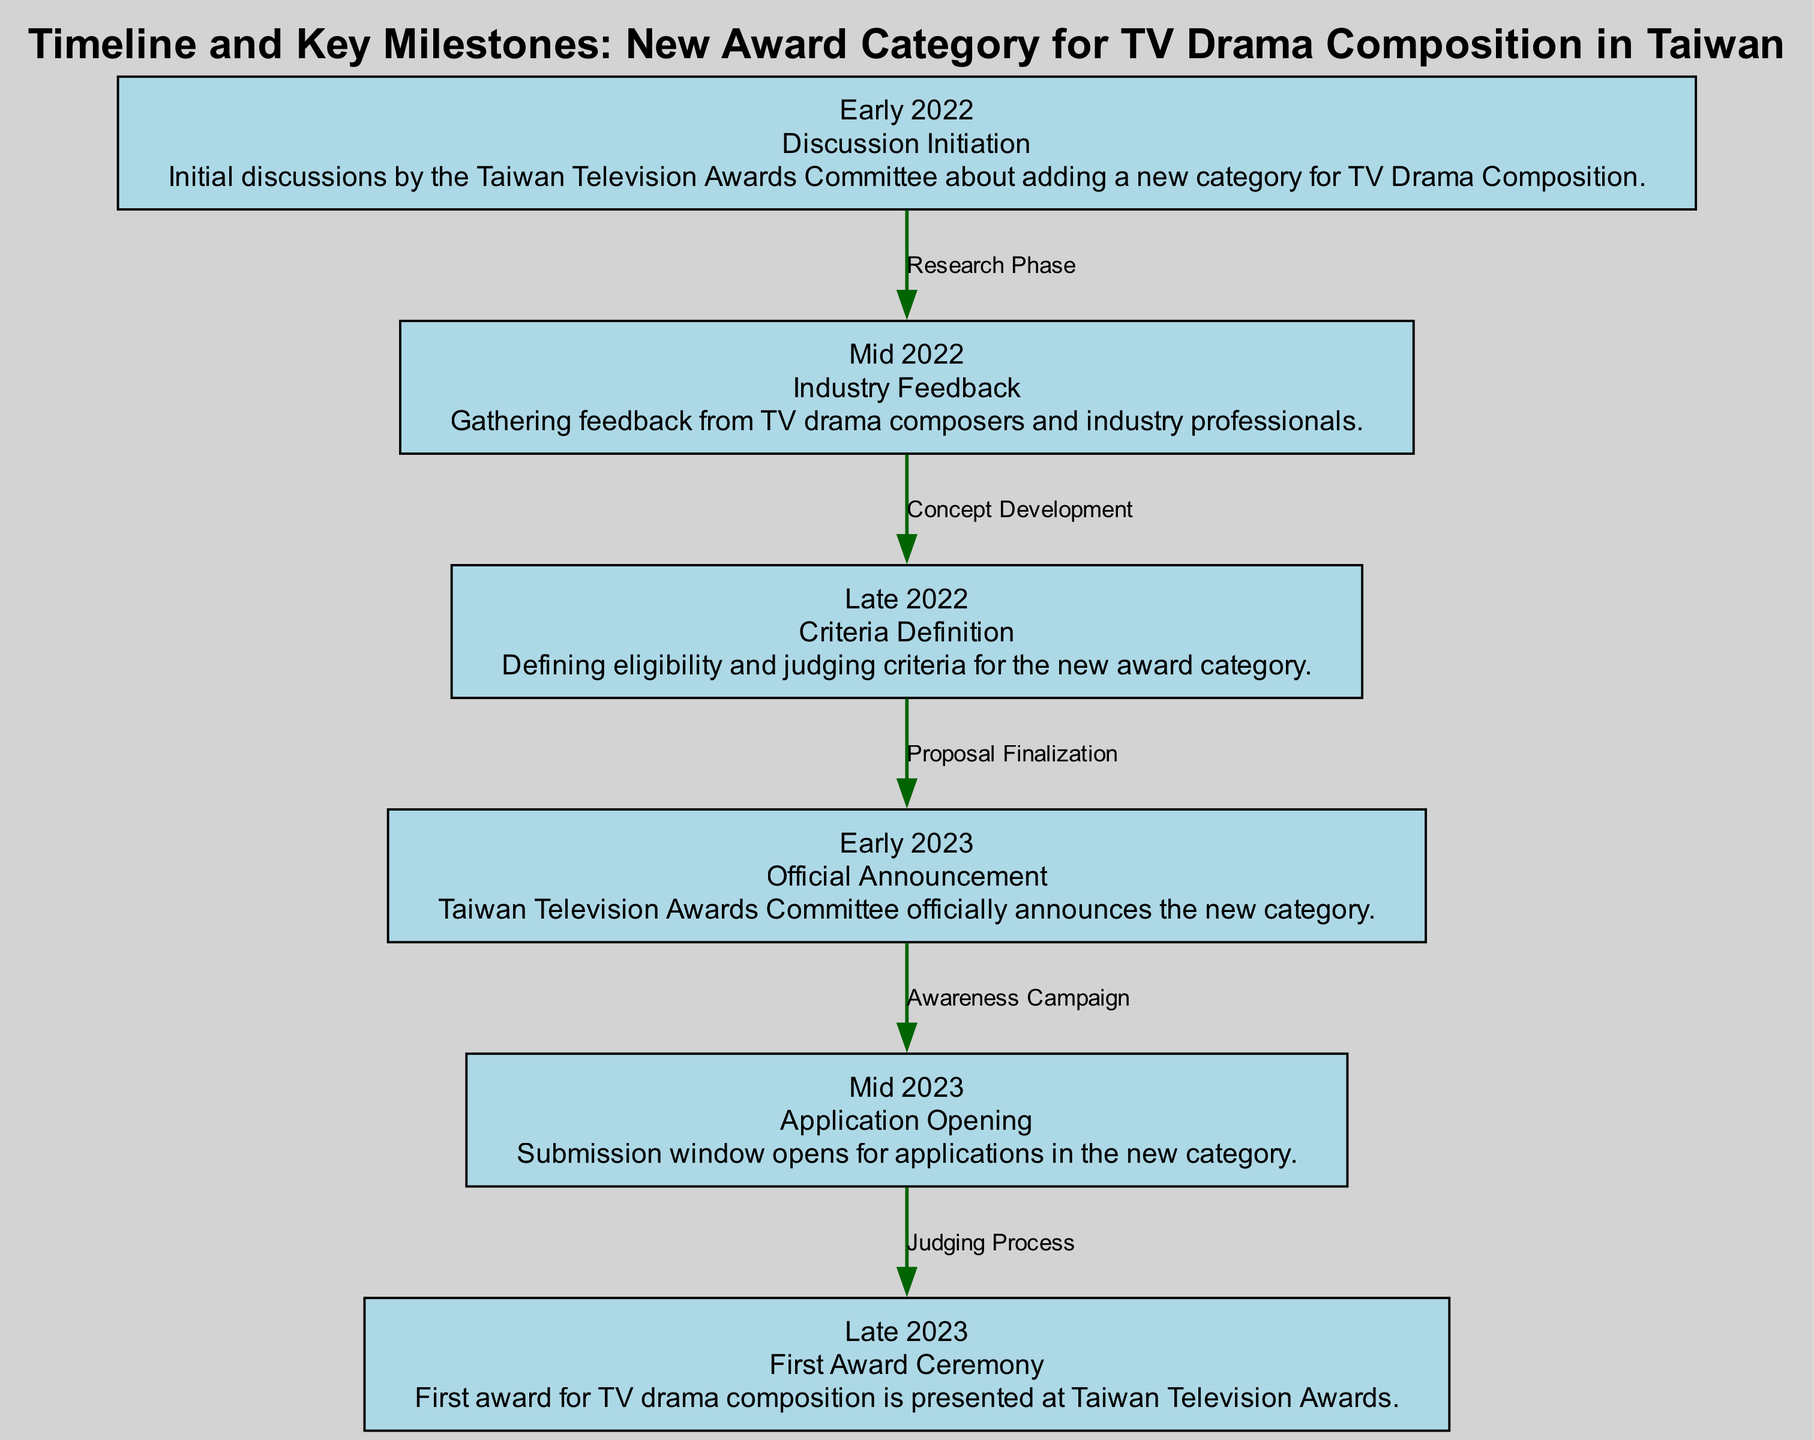What event initiated the discussion for the new award category? The diagram indicates that the discussion initiation took place in Early 2022, marked as the starting event of the timeline.
Answer: Discussion Initiation How many nodes are in this diagram? By counting the distinct elements in the diagram, we find there are six nodes present that represent significant milestones in the timeline.
Answer: 6 What is the label of the node that describes the application opening? In the diagram, the node corresponding to the application opening is labeled "Mid 2023," which denotes when submissions for the new award category began.
Answer: Mid 2023 What relationship exists between the "Criteria Definition" and "Official Announcement" nodes? The diagram shows that the relationship between "Criteria Definition" (Late 2022) and "Official Announcement" (Early 2023) is indicated by the edge labeled "Proposal Finalization." This signifies that after defining the criteria, the proposal was finalized, leading to the announcement.
Answer: Proposal Finalization What is the last key milestone listed in the diagram? According to the timeline presented in the diagram, the final milestone mentioned is in Late 2023, which marks the presentation of the first award for TV drama composition at the ceremony.
Answer: First Award Ceremony How long did it take from the discussion initiation to the official announcement? The duration from "Discussion Initiation" (Early 2022) to "Official Announcement" (Early 2023) spans a total of about one year, as it includes all phases and milestones in between.
Answer: One year What phase follows the application opening in the timeline? The timeline shows that the phase following "Application Opening" (Mid 2023) is the "Judging Process," indicating what occurs after applications have been submitted.
Answer: Judging Process 